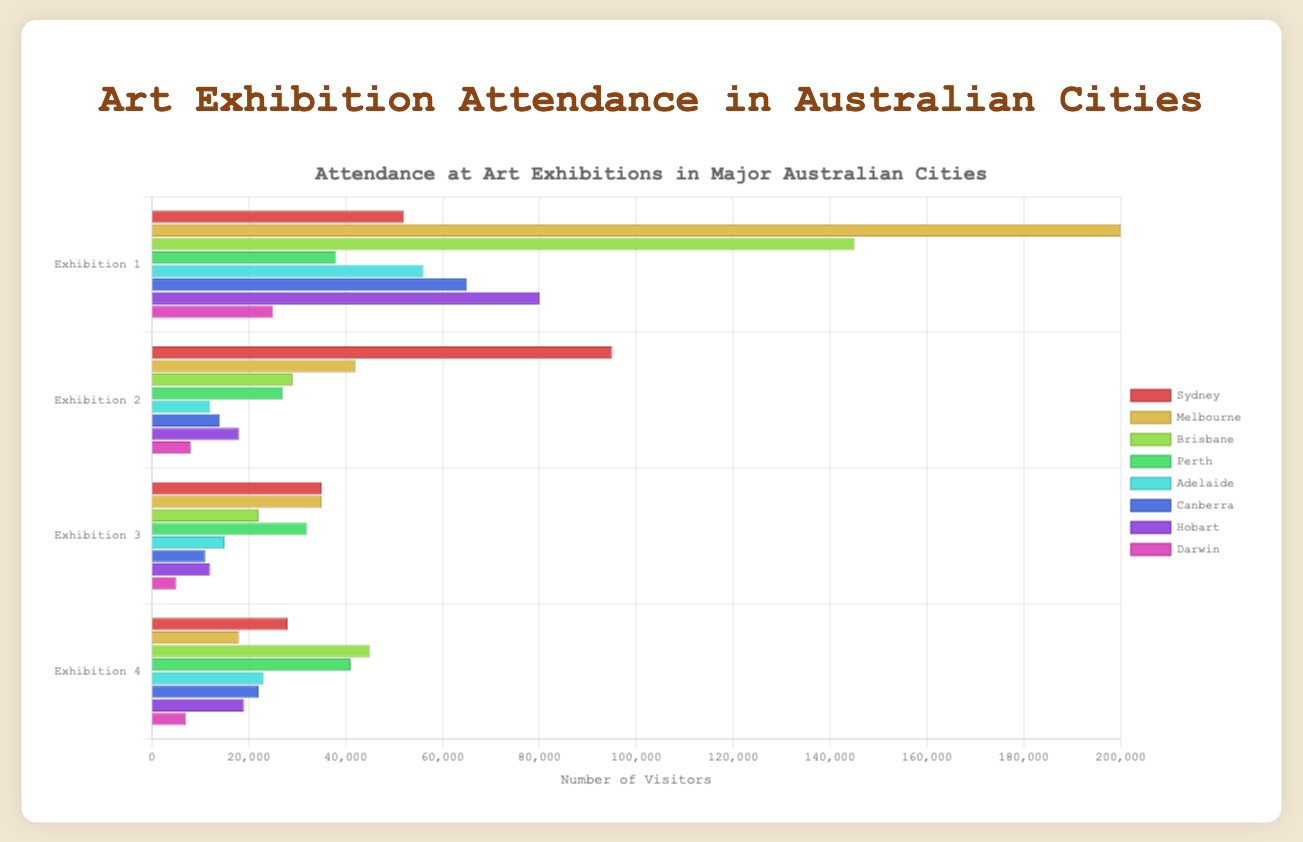What city had the highest attendance for an art exhibition? Melbourne had the highest attendance for an art exhibition with the "NGV - Van Gogh and the Seasons" event. This can be observed from the longest bar in the bar chart for Melbourne, which corresponds to the highest number of visitors, 200,000.
Answer: Melbourne Which exhibition had higher attendance: "MONA - Dark Mofo" in Hobart or "QAGOMA - Water" in Brisbane? By comparing the length of the bars for "MONA - Dark Mofo" in Hobart and "QAGOMA - Water" in Brisbane, it's apparent that the "QAGOMA - Water" exhibition in Brisbane had a higher attendance with 145,000 visitors compared to "MONA - Dark Mofo" with 80,000 visitors.
Answer: QAGOMA - Water Between Sydney and Perth, which city had a greater total attendance across all exhibitions? Sum the attendance for each exhibition in Sydney (52000 + 95000 + 35000 + 28000 = 210000) and in Perth (38000 + 27000 + 32000 + 41000 = 138000). Sydney's total attendance is greater.
Answer: Sydney What is the average attendance of exhibitions in Adelaide? Sum the attendance for all exhibitions in Adelaide (56000 + 12000 + 15000 + 23000 = 106000) and divide by the number of exhibitions (4). Average attendance = 106000 / 4 = 26500.
Answer: 26500 Which city's exhibition had the lowest attendance and what was the attendance number? Identify the smallest bar in the chart, which represents the "Katherine Prize" exhibition at the Godinymayin Yijard Rivers Arts & Culture Centre in Darwin with 5000 attendees.
Answer: Darwin, 5000 How does the attendance for "Art Gallery of South Australia - Tarnanthi" compare to "National Gallery of Australia - Cartier: The Exhibition"? Compare the lengths of the bars for "Art Gallery of South Australia - Tarnanthi" in Adelaide (56000) and "National Gallery of Australia - Cartier: The Exhibition" in Canberra (65000). The latter has a higher attendance.
Answer: National Gallery of Australia - Cartier: The Exhibition What is the difference in attendance between "The Powerhouse - The New Woman" in Brisbane and "AGWA - Beyond Bling!" in Perth? Subtract the attendance of "AGWA - Beyond Bling!" (41000) from "The Powerhouse - The New Woman" (29000). Difference = 29000 - 41000 = -12000.
Answer: -12000 Which exhibition in Sydney had the highest attendance? The longest bar for Sydney corresponds to the "AGNSW - Archibald Prize Exhibition" with 95000 visitors, making it the highest attended exhibition in Sydney.
Answer: AGNSW - Archibald Prize Exhibition Compare the average attendance of exhibitions in Canberra with those in Hobart. Which city had a higher average attendance? Calculate the average attendance for Canberra [(65000 + 14000 + 11000 + 22000) / 4 = 11250] and Hobart [(80000 + 18000 + 12000 + 19000) / 4 = 32250]. Hobart has a higher average attendance.
Answer: Hobart 